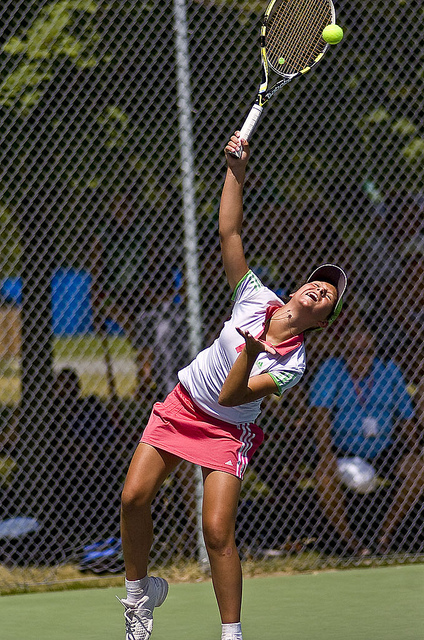Can you describe the technique she is using in this serve? Certainly! The player is utilizing a typical tennis serve technique known as the 'overhead serve.' She is in the motion of throwing the ball up, aligning her racket to strike the ball at a high point, which helps maximize both the speed and angle of the ball's descent over the net. 